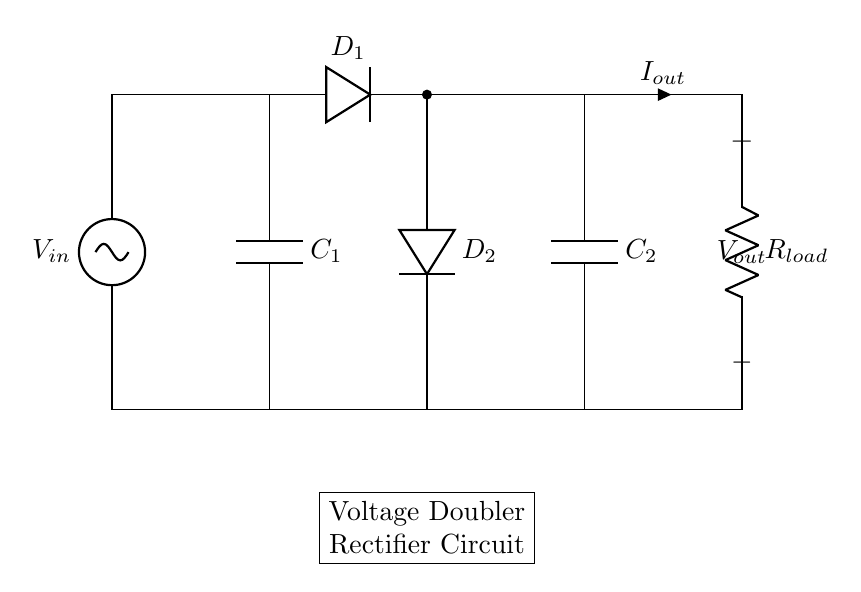What is the input voltage of this circuit? The input voltage is denoted by V in the circuit diagram. This icon represents the source of electrical energy entering the system.
Answer: V in What are the two types of components used in this circuit? The circuit consists of capacitors and diodes as the main components. Capacitors store electrical energy, while diodes control the direction of current flow.
Answer: Capacitors and diodes How many diodes are present in the circuit? There are two diodes labeled as D 1 and D 2 in the circuit diagram, which indicates both are used for rectifying the input voltage.
Answer: Two What is the purpose of C 1 and C 2 in this circuit? C 1 and C 2 are capacitors that serve to store charge and smooth out the output voltage, which effectively helps to double the output voltage.
Answer: To store charge What does R load represent in this circuit? R load represents the load resistor in the circuit, which simulates the component that will consume the output power from the rectifier circuit.
Answer: Load resistor What is the function of a voltage doubler rectifier? The voltage doubler rectifier increases the output voltage, making it suitable for charging batteries by essentially doubling the input voltage value at the output.
Answer: To increase output voltage 